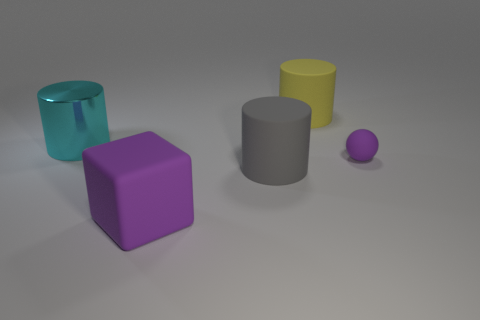Subtract all matte cylinders. How many cylinders are left? 1 Subtract 2 cylinders. How many cylinders are left? 1 Subtract all yellow cylinders. How many cylinders are left? 2 Subtract all green cubes. How many gray cylinders are left? 1 Add 4 large rubber cylinders. How many large rubber cylinders exist? 6 Add 3 purple rubber balls. How many objects exist? 8 Subtract 1 cyan cylinders. How many objects are left? 4 Subtract all balls. How many objects are left? 4 Subtract all brown blocks. Subtract all brown cylinders. How many blocks are left? 1 Subtract all big rubber objects. Subtract all matte cylinders. How many objects are left? 0 